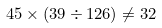<formula> <loc_0><loc_0><loc_500><loc_500>4 5 \times ( 3 9 \div 1 2 6 ) \neq 3 2</formula> 